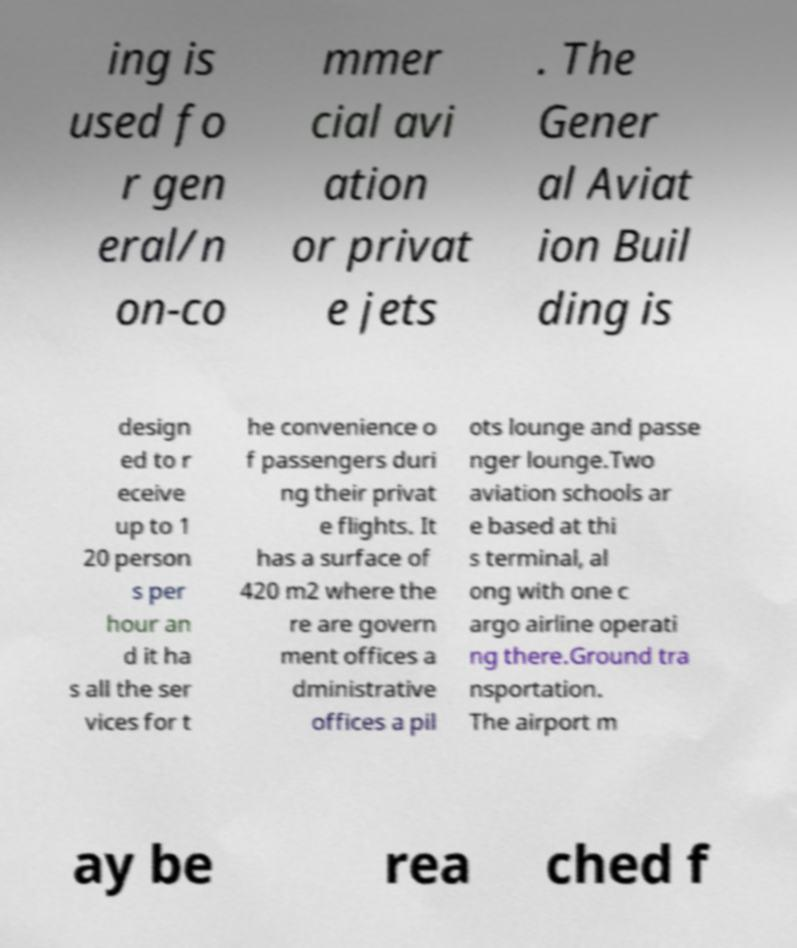Could you extract and type out the text from this image? ing is used fo r gen eral/n on-co mmer cial avi ation or privat e jets . The Gener al Aviat ion Buil ding is design ed to r eceive up to 1 20 person s per hour an d it ha s all the ser vices for t he convenience o f passengers duri ng their privat e flights. It has a surface of 420 m2 where the re are govern ment offices a dministrative offices a pil ots lounge and passe nger lounge.Two aviation schools ar e based at thi s terminal, al ong with one c argo airline operati ng there.Ground tra nsportation. The airport m ay be rea ched f 